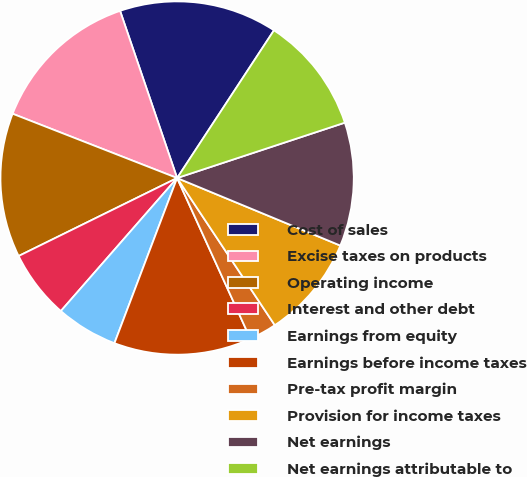Convert chart to OTSL. <chart><loc_0><loc_0><loc_500><loc_500><pie_chart><fcel>Cost of sales<fcel>Excise taxes on products<fcel>Operating income<fcel>Interest and other debt<fcel>Earnings from equity<fcel>Earnings before income taxes<fcel>Pre-tax profit margin<fcel>Provision for income taxes<fcel>Net earnings<fcel>Net earnings attributable to<nl><fcel>14.47%<fcel>13.84%<fcel>13.21%<fcel>6.29%<fcel>5.66%<fcel>12.58%<fcel>2.52%<fcel>9.43%<fcel>11.32%<fcel>10.69%<nl></chart> 